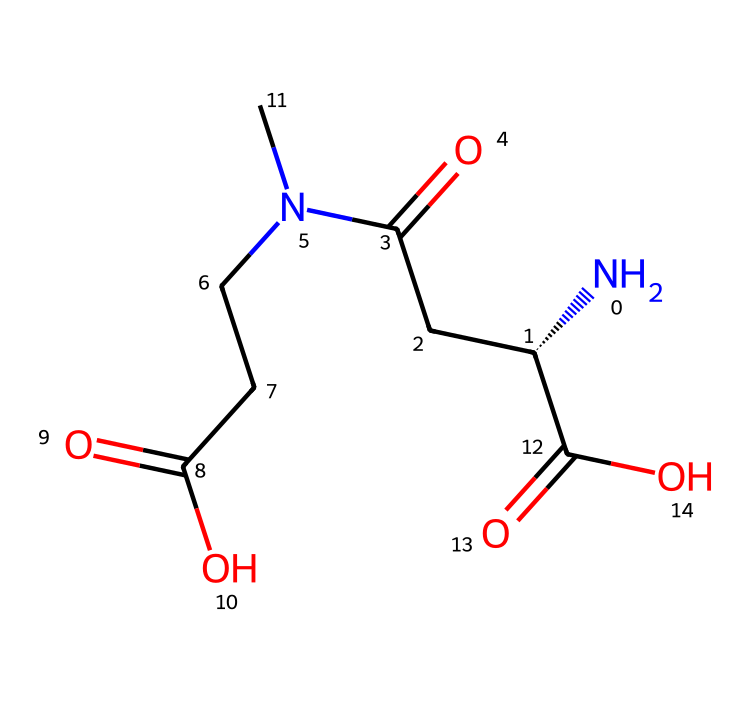What is the molecular formula of L-theanine? By analyzing the SMILES representation, the structure consists of 8 carbon atoms (C), 14 hydrogen atoms (H), 2 nitrogen atoms (N), and 4 oxygen atoms (O). Thus, the molecular formula is calculated as C8H14N2O4.
Answer: C8H14N2O4 How many chiral centers are present in L-theanine? In the given SMILES structure, there is one carbon atom with a four different substituents attached, which is characteristic of a chiral center. This indicates that L-theanine has one chiral center.
Answer: 1 What type of amino acid is L-theanine classified as? L-theanine is classified as a non-proteinogenic amino acid, meaning it is not incorporated into proteins during translation, and its structure aligns with that of classical amino acids due to the presence of both an amino group and a carboxylic acid group.
Answer: non-proteinogenic What functional groups are in L-theanine? The structure exhibits several functional groups: an amino group (–NH2), two carboxylic acid groups (–COOH), and a carbonyl group (=O) present in the amide link. Identifying these helps to understand its reactivity and properties.
Answer: amino, carboxylic acids Is L-theanine a cage compound? Considering cage compounds are characterized by having a polyhedral structure with a three-dimensional arrangement, L-theanine lacks this structure and is therefore not classified as a cage compound.
Answer: no 